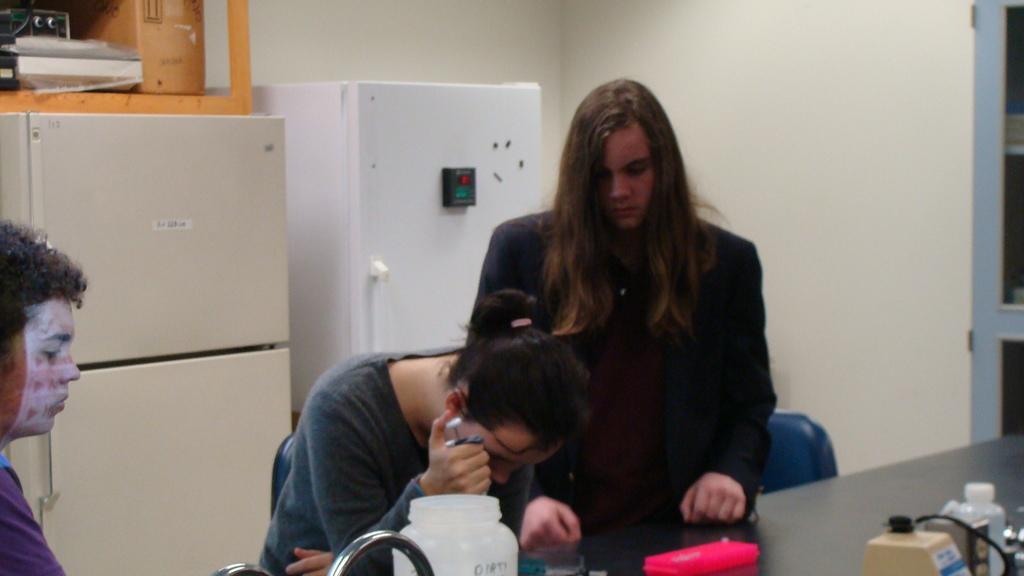How would you summarize this image in a sentence or two? In this image we can see two women standing. In that a woman is holding an object. We can also see a table beside them containing a metal pole, some containers, wire and some objects placed on it. On the left side we can see a person sitting. On the backside we can see a cardboard box and a device placed on a refrigerator and an electrical device beside it. We can also see a cupboard with racks and a wall. 